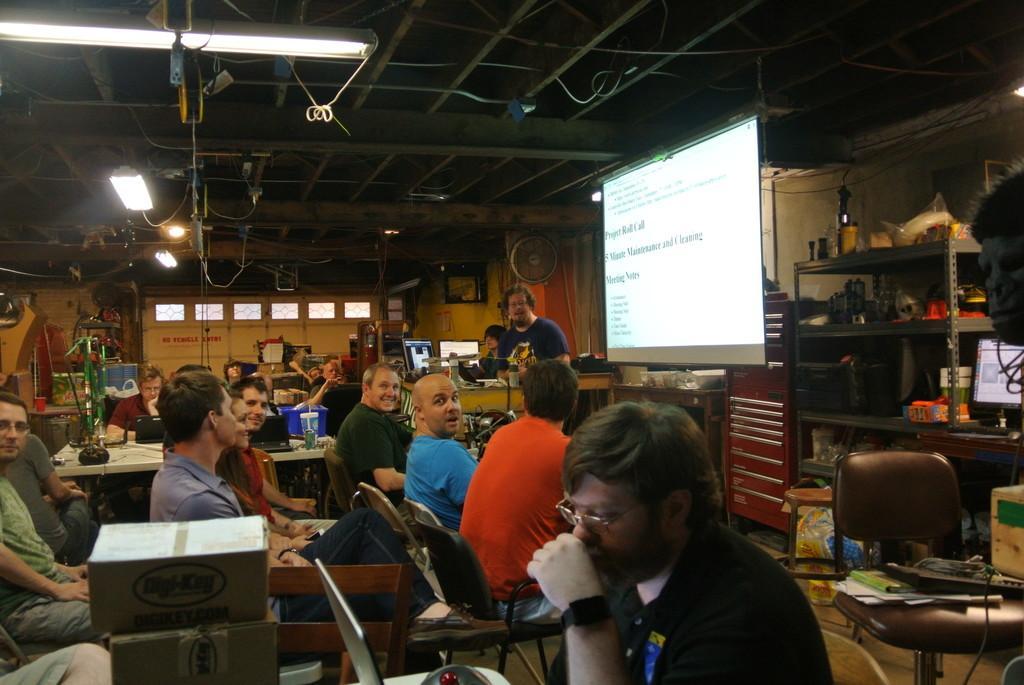Describe this image in one or two sentences. This picture is clicked inside a room. Here, we see many people sitting on chair. On the left corner of the picture, we see projector screen with some text displayed on it. In front of that, we see a man in blue t-shirt is standing near table and on table, we see two laptops. Behind them, we see a white wall. On the top of the picture, we see the ceiling of that room. 